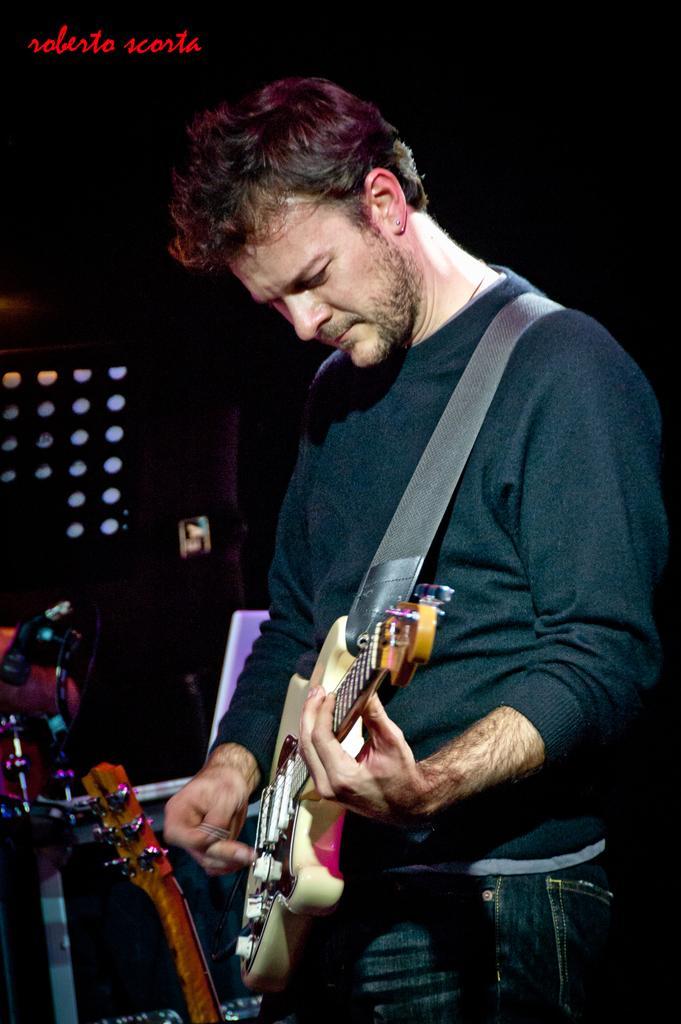Can you describe this image briefly? The image consists of a man who is playing guitar, there are also few instruments beside him, in the background there is a black color wall and also few lights. 